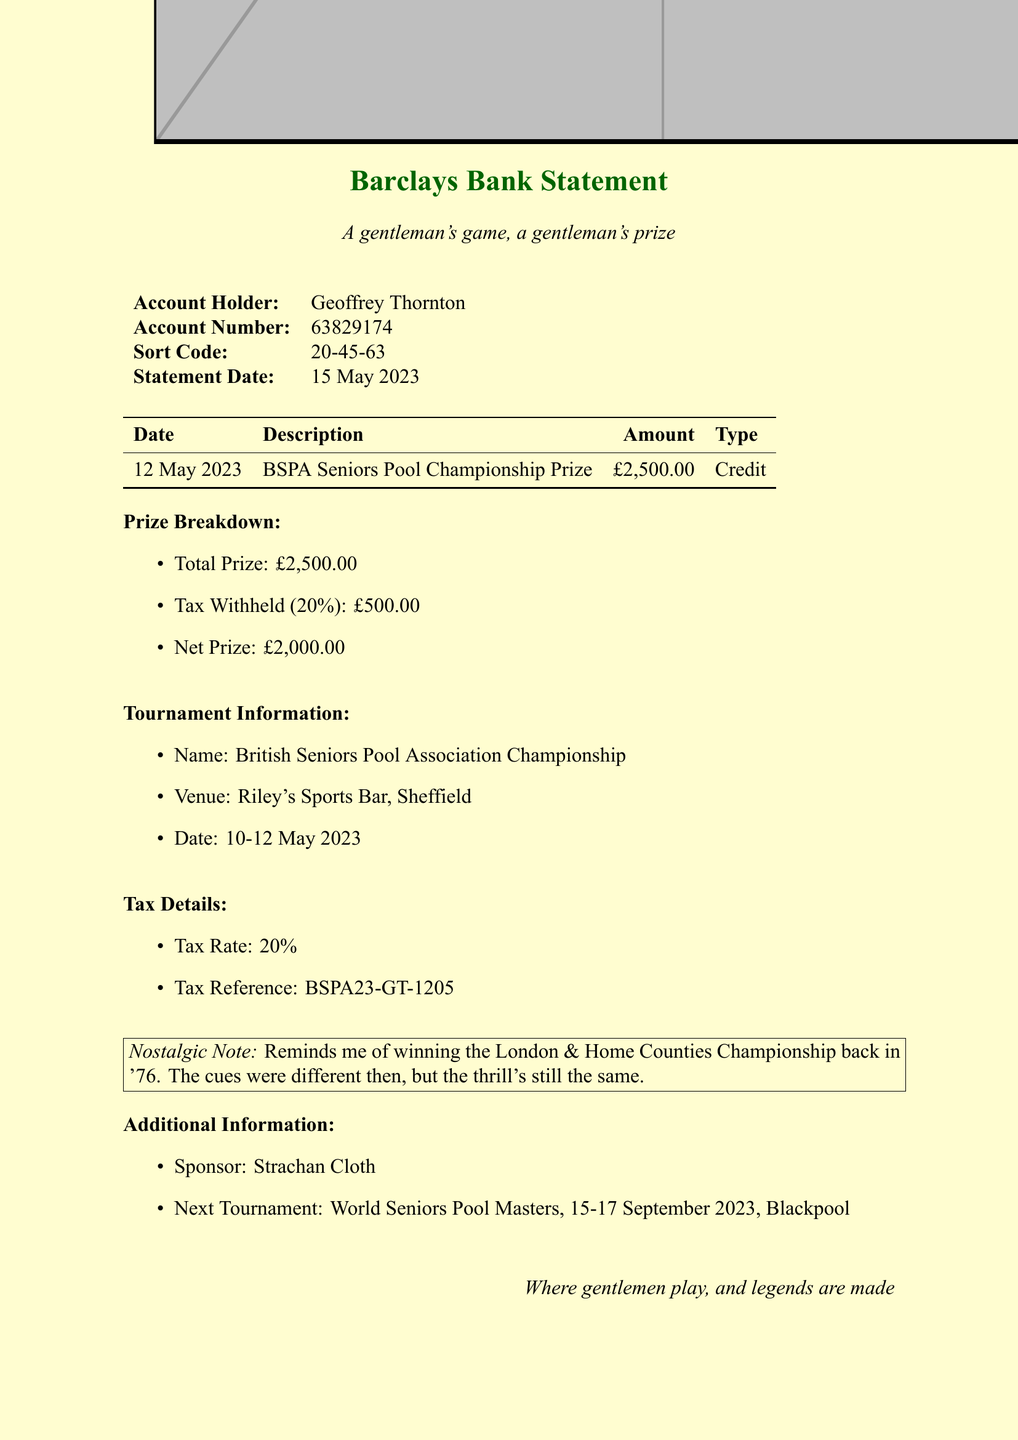what is the bank name? The bank name is stated at the top of the document.
Answer: Barclays who is the account holder? The account holder's name is provided in the account details section.
Answer: Geoffrey Thornton what was the total prize amount? The total prize amount is listed in the prize breakdown section.
Answer: £2,500.00 how much tax was withheld? The tax withheld amount is specified in the prize breakdown section.
Answer: £500.00 what is the net prize? The net prize amount is given in the prize breakdown section as well.
Answer: £2,000.00 what was the venue for the tournament? The venue for the tournament is mentioned in the tournament information section.
Answer: Riley's Sports Bar, Sheffield what percentage is the tax rate? The tax rate is clearly indicated in the tax details section of the document.
Answer: 20% what is the tax reference number? The tax reference is listed in the tax details for identification purposes.
Answer: BSPA23-GT-1205 what is the name of the next tournament? The name of the next tournament is found in the additional information section.
Answer: World Seniors Pool Masters what nostalgic event is mentioned? A nostalgic note references a past event detailed in the document.
Answer: London & Home Counties Championship 